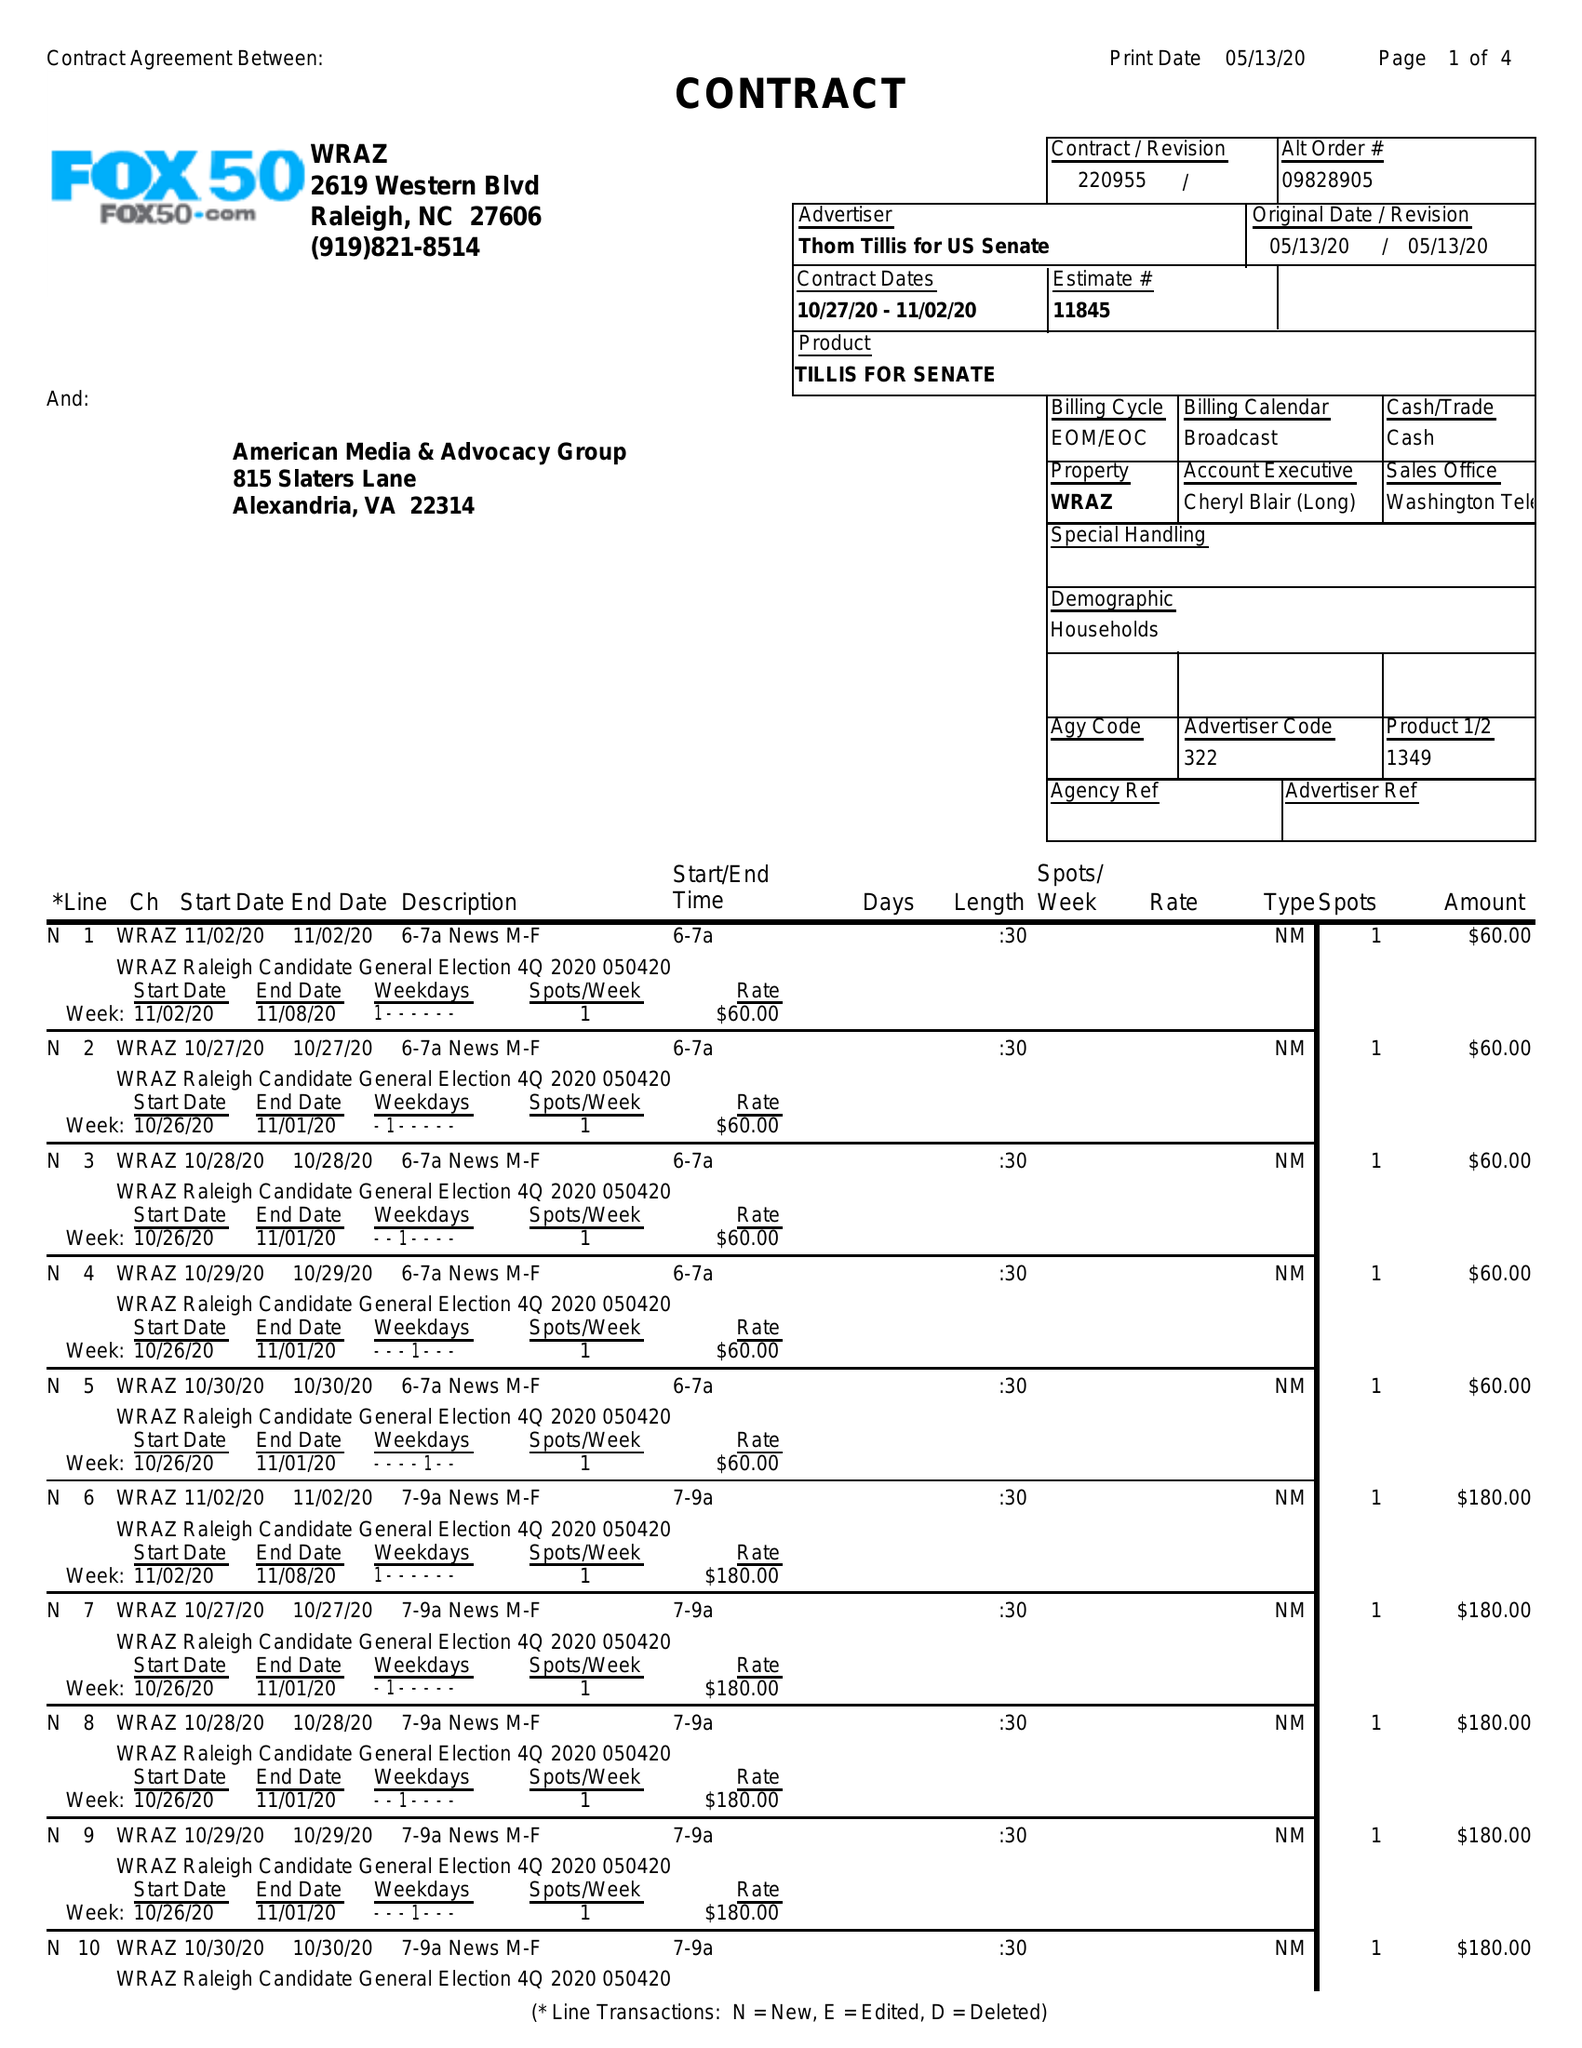What is the value for the contract_num?
Answer the question using a single word or phrase. 220955 